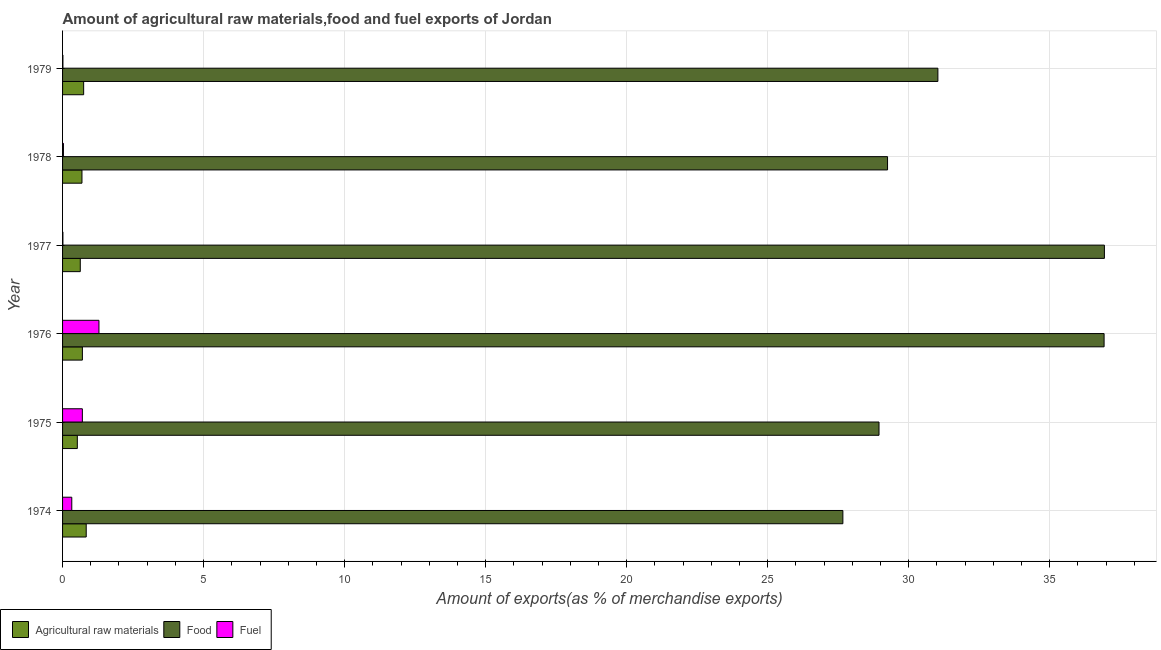How many different coloured bars are there?
Give a very brief answer. 3. Are the number of bars per tick equal to the number of legend labels?
Offer a terse response. Yes. Are the number of bars on each tick of the Y-axis equal?
Your answer should be compact. Yes. How many bars are there on the 6th tick from the top?
Ensure brevity in your answer.  3. What is the label of the 4th group of bars from the top?
Offer a very short reply. 1976. What is the percentage of fuel exports in 1975?
Provide a succinct answer. 0.7. Across all years, what is the maximum percentage of raw materials exports?
Your response must be concise. 0.84. Across all years, what is the minimum percentage of fuel exports?
Keep it short and to the point. 0.01. In which year was the percentage of food exports maximum?
Ensure brevity in your answer.  1977. In which year was the percentage of raw materials exports minimum?
Provide a succinct answer. 1975. What is the total percentage of fuel exports in the graph?
Your answer should be very brief. 2.37. What is the difference between the percentage of fuel exports in 1976 and that in 1978?
Offer a terse response. 1.26. What is the difference between the percentage of fuel exports in 1978 and the percentage of food exports in 1974?
Provide a short and direct response. -27.64. What is the average percentage of raw materials exports per year?
Offer a terse response. 0.69. In the year 1975, what is the difference between the percentage of fuel exports and percentage of raw materials exports?
Make the answer very short. 0.18. What is the ratio of the percentage of fuel exports in 1976 to that in 1977?
Your response must be concise. 107.68. What is the difference between the highest and the second highest percentage of food exports?
Make the answer very short. 0.01. What is the difference between the highest and the lowest percentage of raw materials exports?
Provide a succinct answer. 0.32. What does the 3rd bar from the top in 1976 represents?
Your answer should be compact. Agricultural raw materials. What does the 2nd bar from the bottom in 1976 represents?
Keep it short and to the point. Food. How many years are there in the graph?
Provide a succinct answer. 6. Does the graph contain any zero values?
Ensure brevity in your answer.  No. How are the legend labels stacked?
Keep it short and to the point. Horizontal. What is the title of the graph?
Give a very brief answer. Amount of agricultural raw materials,food and fuel exports of Jordan. Does "Social insurance" appear as one of the legend labels in the graph?
Your response must be concise. No. What is the label or title of the X-axis?
Keep it short and to the point. Amount of exports(as % of merchandise exports). What is the label or title of the Y-axis?
Your response must be concise. Year. What is the Amount of exports(as % of merchandise exports) in Agricultural raw materials in 1974?
Provide a succinct answer. 0.84. What is the Amount of exports(as % of merchandise exports) in Food in 1974?
Ensure brevity in your answer.  27.67. What is the Amount of exports(as % of merchandise exports) in Fuel in 1974?
Make the answer very short. 0.33. What is the Amount of exports(as % of merchandise exports) of Agricultural raw materials in 1975?
Keep it short and to the point. 0.52. What is the Amount of exports(as % of merchandise exports) of Food in 1975?
Your response must be concise. 28.95. What is the Amount of exports(as % of merchandise exports) of Fuel in 1975?
Make the answer very short. 0.7. What is the Amount of exports(as % of merchandise exports) in Agricultural raw materials in 1976?
Your answer should be compact. 0.7. What is the Amount of exports(as % of merchandise exports) in Food in 1976?
Your answer should be very brief. 36.93. What is the Amount of exports(as % of merchandise exports) of Fuel in 1976?
Offer a terse response. 1.29. What is the Amount of exports(as % of merchandise exports) in Agricultural raw materials in 1977?
Provide a short and direct response. 0.63. What is the Amount of exports(as % of merchandise exports) in Food in 1977?
Offer a very short reply. 36.94. What is the Amount of exports(as % of merchandise exports) of Fuel in 1977?
Your response must be concise. 0.01. What is the Amount of exports(as % of merchandise exports) in Agricultural raw materials in 1978?
Provide a short and direct response. 0.69. What is the Amount of exports(as % of merchandise exports) of Food in 1978?
Offer a very short reply. 29.25. What is the Amount of exports(as % of merchandise exports) in Fuel in 1978?
Provide a short and direct response. 0.03. What is the Amount of exports(as % of merchandise exports) in Agricultural raw materials in 1979?
Provide a short and direct response. 0.75. What is the Amount of exports(as % of merchandise exports) in Food in 1979?
Provide a short and direct response. 31.03. What is the Amount of exports(as % of merchandise exports) in Fuel in 1979?
Keep it short and to the point. 0.01. Across all years, what is the maximum Amount of exports(as % of merchandise exports) in Agricultural raw materials?
Offer a terse response. 0.84. Across all years, what is the maximum Amount of exports(as % of merchandise exports) of Food?
Ensure brevity in your answer.  36.94. Across all years, what is the maximum Amount of exports(as % of merchandise exports) of Fuel?
Ensure brevity in your answer.  1.29. Across all years, what is the minimum Amount of exports(as % of merchandise exports) of Agricultural raw materials?
Keep it short and to the point. 0.52. Across all years, what is the minimum Amount of exports(as % of merchandise exports) of Food?
Offer a very short reply. 27.67. Across all years, what is the minimum Amount of exports(as % of merchandise exports) in Fuel?
Keep it short and to the point. 0.01. What is the total Amount of exports(as % of merchandise exports) in Agricultural raw materials in the graph?
Give a very brief answer. 4.13. What is the total Amount of exports(as % of merchandise exports) in Food in the graph?
Your answer should be very brief. 190.77. What is the total Amount of exports(as % of merchandise exports) in Fuel in the graph?
Offer a very short reply. 2.37. What is the difference between the Amount of exports(as % of merchandise exports) in Agricultural raw materials in 1974 and that in 1975?
Provide a short and direct response. 0.32. What is the difference between the Amount of exports(as % of merchandise exports) in Food in 1974 and that in 1975?
Offer a very short reply. -1.28. What is the difference between the Amount of exports(as % of merchandise exports) in Fuel in 1974 and that in 1975?
Offer a terse response. -0.38. What is the difference between the Amount of exports(as % of merchandise exports) of Agricultural raw materials in 1974 and that in 1976?
Provide a succinct answer. 0.14. What is the difference between the Amount of exports(as % of merchandise exports) of Food in 1974 and that in 1976?
Provide a short and direct response. -9.26. What is the difference between the Amount of exports(as % of merchandise exports) of Fuel in 1974 and that in 1976?
Your answer should be very brief. -0.96. What is the difference between the Amount of exports(as % of merchandise exports) of Agricultural raw materials in 1974 and that in 1977?
Your answer should be very brief. 0.21. What is the difference between the Amount of exports(as % of merchandise exports) in Food in 1974 and that in 1977?
Keep it short and to the point. -9.27. What is the difference between the Amount of exports(as % of merchandise exports) of Fuel in 1974 and that in 1977?
Offer a terse response. 0.31. What is the difference between the Amount of exports(as % of merchandise exports) of Agricultural raw materials in 1974 and that in 1978?
Provide a short and direct response. 0.15. What is the difference between the Amount of exports(as % of merchandise exports) in Food in 1974 and that in 1978?
Offer a very short reply. -1.58. What is the difference between the Amount of exports(as % of merchandise exports) of Fuel in 1974 and that in 1978?
Offer a very short reply. 0.3. What is the difference between the Amount of exports(as % of merchandise exports) in Agricultural raw materials in 1974 and that in 1979?
Keep it short and to the point. 0.09. What is the difference between the Amount of exports(as % of merchandise exports) of Food in 1974 and that in 1979?
Your answer should be very brief. -3.37. What is the difference between the Amount of exports(as % of merchandise exports) in Fuel in 1974 and that in 1979?
Offer a very short reply. 0.31. What is the difference between the Amount of exports(as % of merchandise exports) in Agricultural raw materials in 1975 and that in 1976?
Ensure brevity in your answer.  -0.18. What is the difference between the Amount of exports(as % of merchandise exports) in Food in 1975 and that in 1976?
Your response must be concise. -7.98. What is the difference between the Amount of exports(as % of merchandise exports) in Fuel in 1975 and that in 1976?
Your answer should be very brief. -0.59. What is the difference between the Amount of exports(as % of merchandise exports) of Agricultural raw materials in 1975 and that in 1977?
Your answer should be very brief. -0.1. What is the difference between the Amount of exports(as % of merchandise exports) in Food in 1975 and that in 1977?
Ensure brevity in your answer.  -7.99. What is the difference between the Amount of exports(as % of merchandise exports) of Fuel in 1975 and that in 1977?
Offer a terse response. 0.69. What is the difference between the Amount of exports(as % of merchandise exports) of Agricultural raw materials in 1975 and that in 1978?
Your answer should be very brief. -0.16. What is the difference between the Amount of exports(as % of merchandise exports) in Food in 1975 and that in 1978?
Keep it short and to the point. -0.3. What is the difference between the Amount of exports(as % of merchandise exports) of Fuel in 1975 and that in 1978?
Your answer should be very brief. 0.67. What is the difference between the Amount of exports(as % of merchandise exports) in Agricultural raw materials in 1975 and that in 1979?
Keep it short and to the point. -0.22. What is the difference between the Amount of exports(as % of merchandise exports) of Food in 1975 and that in 1979?
Keep it short and to the point. -2.09. What is the difference between the Amount of exports(as % of merchandise exports) in Fuel in 1975 and that in 1979?
Your answer should be very brief. 0.69. What is the difference between the Amount of exports(as % of merchandise exports) in Agricultural raw materials in 1976 and that in 1977?
Offer a very short reply. 0.07. What is the difference between the Amount of exports(as % of merchandise exports) of Food in 1976 and that in 1977?
Ensure brevity in your answer.  -0.01. What is the difference between the Amount of exports(as % of merchandise exports) in Fuel in 1976 and that in 1977?
Your answer should be very brief. 1.28. What is the difference between the Amount of exports(as % of merchandise exports) in Agricultural raw materials in 1976 and that in 1978?
Offer a terse response. 0.01. What is the difference between the Amount of exports(as % of merchandise exports) in Food in 1976 and that in 1978?
Your answer should be very brief. 7.68. What is the difference between the Amount of exports(as % of merchandise exports) in Fuel in 1976 and that in 1978?
Your answer should be very brief. 1.26. What is the difference between the Amount of exports(as % of merchandise exports) of Agricultural raw materials in 1976 and that in 1979?
Keep it short and to the point. -0.04. What is the difference between the Amount of exports(as % of merchandise exports) in Food in 1976 and that in 1979?
Offer a very short reply. 5.89. What is the difference between the Amount of exports(as % of merchandise exports) of Fuel in 1976 and that in 1979?
Keep it short and to the point. 1.28. What is the difference between the Amount of exports(as % of merchandise exports) in Agricultural raw materials in 1977 and that in 1978?
Provide a succinct answer. -0.06. What is the difference between the Amount of exports(as % of merchandise exports) in Food in 1977 and that in 1978?
Offer a terse response. 7.69. What is the difference between the Amount of exports(as % of merchandise exports) of Fuel in 1977 and that in 1978?
Provide a succinct answer. -0.02. What is the difference between the Amount of exports(as % of merchandise exports) in Agricultural raw materials in 1977 and that in 1979?
Your answer should be very brief. -0.12. What is the difference between the Amount of exports(as % of merchandise exports) of Food in 1977 and that in 1979?
Provide a short and direct response. 5.9. What is the difference between the Amount of exports(as % of merchandise exports) in Fuel in 1977 and that in 1979?
Provide a short and direct response. -0. What is the difference between the Amount of exports(as % of merchandise exports) of Agricultural raw materials in 1978 and that in 1979?
Offer a terse response. -0.06. What is the difference between the Amount of exports(as % of merchandise exports) of Food in 1978 and that in 1979?
Your answer should be very brief. -1.78. What is the difference between the Amount of exports(as % of merchandise exports) of Fuel in 1978 and that in 1979?
Provide a short and direct response. 0.02. What is the difference between the Amount of exports(as % of merchandise exports) in Agricultural raw materials in 1974 and the Amount of exports(as % of merchandise exports) in Food in 1975?
Offer a terse response. -28.11. What is the difference between the Amount of exports(as % of merchandise exports) of Agricultural raw materials in 1974 and the Amount of exports(as % of merchandise exports) of Fuel in 1975?
Make the answer very short. 0.14. What is the difference between the Amount of exports(as % of merchandise exports) in Food in 1974 and the Amount of exports(as % of merchandise exports) in Fuel in 1975?
Provide a succinct answer. 26.96. What is the difference between the Amount of exports(as % of merchandise exports) in Agricultural raw materials in 1974 and the Amount of exports(as % of merchandise exports) in Food in 1976?
Make the answer very short. -36.09. What is the difference between the Amount of exports(as % of merchandise exports) in Agricultural raw materials in 1974 and the Amount of exports(as % of merchandise exports) in Fuel in 1976?
Keep it short and to the point. -0.45. What is the difference between the Amount of exports(as % of merchandise exports) in Food in 1974 and the Amount of exports(as % of merchandise exports) in Fuel in 1976?
Offer a very short reply. 26.38. What is the difference between the Amount of exports(as % of merchandise exports) of Agricultural raw materials in 1974 and the Amount of exports(as % of merchandise exports) of Food in 1977?
Offer a very short reply. -36.1. What is the difference between the Amount of exports(as % of merchandise exports) in Agricultural raw materials in 1974 and the Amount of exports(as % of merchandise exports) in Fuel in 1977?
Provide a short and direct response. 0.83. What is the difference between the Amount of exports(as % of merchandise exports) of Food in 1974 and the Amount of exports(as % of merchandise exports) of Fuel in 1977?
Your answer should be very brief. 27.65. What is the difference between the Amount of exports(as % of merchandise exports) in Agricultural raw materials in 1974 and the Amount of exports(as % of merchandise exports) in Food in 1978?
Your answer should be compact. -28.41. What is the difference between the Amount of exports(as % of merchandise exports) of Agricultural raw materials in 1974 and the Amount of exports(as % of merchandise exports) of Fuel in 1978?
Provide a succinct answer. 0.81. What is the difference between the Amount of exports(as % of merchandise exports) in Food in 1974 and the Amount of exports(as % of merchandise exports) in Fuel in 1978?
Keep it short and to the point. 27.64. What is the difference between the Amount of exports(as % of merchandise exports) of Agricultural raw materials in 1974 and the Amount of exports(as % of merchandise exports) of Food in 1979?
Provide a succinct answer. -30.2. What is the difference between the Amount of exports(as % of merchandise exports) of Agricultural raw materials in 1974 and the Amount of exports(as % of merchandise exports) of Fuel in 1979?
Provide a succinct answer. 0.83. What is the difference between the Amount of exports(as % of merchandise exports) of Food in 1974 and the Amount of exports(as % of merchandise exports) of Fuel in 1979?
Ensure brevity in your answer.  27.65. What is the difference between the Amount of exports(as % of merchandise exports) in Agricultural raw materials in 1975 and the Amount of exports(as % of merchandise exports) in Food in 1976?
Your answer should be very brief. -36.4. What is the difference between the Amount of exports(as % of merchandise exports) in Agricultural raw materials in 1975 and the Amount of exports(as % of merchandise exports) in Fuel in 1976?
Your answer should be compact. -0.77. What is the difference between the Amount of exports(as % of merchandise exports) of Food in 1975 and the Amount of exports(as % of merchandise exports) of Fuel in 1976?
Provide a short and direct response. 27.66. What is the difference between the Amount of exports(as % of merchandise exports) of Agricultural raw materials in 1975 and the Amount of exports(as % of merchandise exports) of Food in 1977?
Make the answer very short. -36.42. What is the difference between the Amount of exports(as % of merchandise exports) of Agricultural raw materials in 1975 and the Amount of exports(as % of merchandise exports) of Fuel in 1977?
Your answer should be compact. 0.51. What is the difference between the Amount of exports(as % of merchandise exports) in Food in 1975 and the Amount of exports(as % of merchandise exports) in Fuel in 1977?
Keep it short and to the point. 28.94. What is the difference between the Amount of exports(as % of merchandise exports) in Agricultural raw materials in 1975 and the Amount of exports(as % of merchandise exports) in Food in 1978?
Provide a succinct answer. -28.73. What is the difference between the Amount of exports(as % of merchandise exports) of Agricultural raw materials in 1975 and the Amount of exports(as % of merchandise exports) of Fuel in 1978?
Offer a very short reply. 0.49. What is the difference between the Amount of exports(as % of merchandise exports) in Food in 1975 and the Amount of exports(as % of merchandise exports) in Fuel in 1978?
Give a very brief answer. 28.92. What is the difference between the Amount of exports(as % of merchandise exports) in Agricultural raw materials in 1975 and the Amount of exports(as % of merchandise exports) in Food in 1979?
Give a very brief answer. -30.51. What is the difference between the Amount of exports(as % of merchandise exports) in Agricultural raw materials in 1975 and the Amount of exports(as % of merchandise exports) in Fuel in 1979?
Provide a succinct answer. 0.51. What is the difference between the Amount of exports(as % of merchandise exports) of Food in 1975 and the Amount of exports(as % of merchandise exports) of Fuel in 1979?
Your answer should be very brief. 28.93. What is the difference between the Amount of exports(as % of merchandise exports) of Agricultural raw materials in 1976 and the Amount of exports(as % of merchandise exports) of Food in 1977?
Offer a very short reply. -36.24. What is the difference between the Amount of exports(as % of merchandise exports) in Agricultural raw materials in 1976 and the Amount of exports(as % of merchandise exports) in Fuel in 1977?
Give a very brief answer. 0.69. What is the difference between the Amount of exports(as % of merchandise exports) in Food in 1976 and the Amount of exports(as % of merchandise exports) in Fuel in 1977?
Offer a terse response. 36.92. What is the difference between the Amount of exports(as % of merchandise exports) in Agricultural raw materials in 1976 and the Amount of exports(as % of merchandise exports) in Food in 1978?
Ensure brevity in your answer.  -28.55. What is the difference between the Amount of exports(as % of merchandise exports) in Agricultural raw materials in 1976 and the Amount of exports(as % of merchandise exports) in Fuel in 1978?
Ensure brevity in your answer.  0.67. What is the difference between the Amount of exports(as % of merchandise exports) of Food in 1976 and the Amount of exports(as % of merchandise exports) of Fuel in 1978?
Your response must be concise. 36.9. What is the difference between the Amount of exports(as % of merchandise exports) in Agricultural raw materials in 1976 and the Amount of exports(as % of merchandise exports) in Food in 1979?
Offer a terse response. -30.33. What is the difference between the Amount of exports(as % of merchandise exports) of Agricultural raw materials in 1976 and the Amount of exports(as % of merchandise exports) of Fuel in 1979?
Provide a succinct answer. 0.69. What is the difference between the Amount of exports(as % of merchandise exports) of Food in 1976 and the Amount of exports(as % of merchandise exports) of Fuel in 1979?
Offer a terse response. 36.91. What is the difference between the Amount of exports(as % of merchandise exports) in Agricultural raw materials in 1977 and the Amount of exports(as % of merchandise exports) in Food in 1978?
Offer a terse response. -28.62. What is the difference between the Amount of exports(as % of merchandise exports) in Agricultural raw materials in 1977 and the Amount of exports(as % of merchandise exports) in Fuel in 1978?
Provide a short and direct response. 0.6. What is the difference between the Amount of exports(as % of merchandise exports) of Food in 1977 and the Amount of exports(as % of merchandise exports) of Fuel in 1978?
Offer a terse response. 36.91. What is the difference between the Amount of exports(as % of merchandise exports) of Agricultural raw materials in 1977 and the Amount of exports(as % of merchandise exports) of Food in 1979?
Your response must be concise. -30.41. What is the difference between the Amount of exports(as % of merchandise exports) of Agricultural raw materials in 1977 and the Amount of exports(as % of merchandise exports) of Fuel in 1979?
Ensure brevity in your answer.  0.62. What is the difference between the Amount of exports(as % of merchandise exports) of Food in 1977 and the Amount of exports(as % of merchandise exports) of Fuel in 1979?
Your answer should be compact. 36.93. What is the difference between the Amount of exports(as % of merchandise exports) in Agricultural raw materials in 1978 and the Amount of exports(as % of merchandise exports) in Food in 1979?
Offer a very short reply. -30.35. What is the difference between the Amount of exports(as % of merchandise exports) in Agricultural raw materials in 1978 and the Amount of exports(as % of merchandise exports) in Fuel in 1979?
Your answer should be very brief. 0.68. What is the difference between the Amount of exports(as % of merchandise exports) in Food in 1978 and the Amount of exports(as % of merchandise exports) in Fuel in 1979?
Give a very brief answer. 29.24. What is the average Amount of exports(as % of merchandise exports) in Agricultural raw materials per year?
Provide a short and direct response. 0.69. What is the average Amount of exports(as % of merchandise exports) in Food per year?
Provide a short and direct response. 31.79. What is the average Amount of exports(as % of merchandise exports) in Fuel per year?
Give a very brief answer. 0.4. In the year 1974, what is the difference between the Amount of exports(as % of merchandise exports) in Agricultural raw materials and Amount of exports(as % of merchandise exports) in Food?
Make the answer very short. -26.83. In the year 1974, what is the difference between the Amount of exports(as % of merchandise exports) in Agricultural raw materials and Amount of exports(as % of merchandise exports) in Fuel?
Ensure brevity in your answer.  0.51. In the year 1974, what is the difference between the Amount of exports(as % of merchandise exports) in Food and Amount of exports(as % of merchandise exports) in Fuel?
Your answer should be compact. 27.34. In the year 1975, what is the difference between the Amount of exports(as % of merchandise exports) of Agricultural raw materials and Amount of exports(as % of merchandise exports) of Food?
Your response must be concise. -28.42. In the year 1975, what is the difference between the Amount of exports(as % of merchandise exports) in Agricultural raw materials and Amount of exports(as % of merchandise exports) in Fuel?
Give a very brief answer. -0.18. In the year 1975, what is the difference between the Amount of exports(as % of merchandise exports) in Food and Amount of exports(as % of merchandise exports) in Fuel?
Provide a succinct answer. 28.25. In the year 1976, what is the difference between the Amount of exports(as % of merchandise exports) in Agricultural raw materials and Amount of exports(as % of merchandise exports) in Food?
Provide a short and direct response. -36.22. In the year 1976, what is the difference between the Amount of exports(as % of merchandise exports) in Agricultural raw materials and Amount of exports(as % of merchandise exports) in Fuel?
Ensure brevity in your answer.  -0.59. In the year 1976, what is the difference between the Amount of exports(as % of merchandise exports) in Food and Amount of exports(as % of merchandise exports) in Fuel?
Offer a terse response. 35.64. In the year 1977, what is the difference between the Amount of exports(as % of merchandise exports) in Agricultural raw materials and Amount of exports(as % of merchandise exports) in Food?
Your answer should be compact. -36.31. In the year 1977, what is the difference between the Amount of exports(as % of merchandise exports) in Agricultural raw materials and Amount of exports(as % of merchandise exports) in Fuel?
Your response must be concise. 0.62. In the year 1977, what is the difference between the Amount of exports(as % of merchandise exports) in Food and Amount of exports(as % of merchandise exports) in Fuel?
Ensure brevity in your answer.  36.93. In the year 1978, what is the difference between the Amount of exports(as % of merchandise exports) of Agricultural raw materials and Amount of exports(as % of merchandise exports) of Food?
Your answer should be compact. -28.56. In the year 1978, what is the difference between the Amount of exports(as % of merchandise exports) in Agricultural raw materials and Amount of exports(as % of merchandise exports) in Fuel?
Keep it short and to the point. 0.66. In the year 1978, what is the difference between the Amount of exports(as % of merchandise exports) of Food and Amount of exports(as % of merchandise exports) of Fuel?
Provide a short and direct response. 29.22. In the year 1979, what is the difference between the Amount of exports(as % of merchandise exports) of Agricultural raw materials and Amount of exports(as % of merchandise exports) of Food?
Provide a short and direct response. -30.29. In the year 1979, what is the difference between the Amount of exports(as % of merchandise exports) in Agricultural raw materials and Amount of exports(as % of merchandise exports) in Fuel?
Offer a very short reply. 0.74. In the year 1979, what is the difference between the Amount of exports(as % of merchandise exports) of Food and Amount of exports(as % of merchandise exports) of Fuel?
Keep it short and to the point. 31.02. What is the ratio of the Amount of exports(as % of merchandise exports) of Agricultural raw materials in 1974 to that in 1975?
Make the answer very short. 1.6. What is the ratio of the Amount of exports(as % of merchandise exports) of Food in 1974 to that in 1975?
Your answer should be compact. 0.96. What is the ratio of the Amount of exports(as % of merchandise exports) of Fuel in 1974 to that in 1975?
Your answer should be very brief. 0.47. What is the ratio of the Amount of exports(as % of merchandise exports) in Agricultural raw materials in 1974 to that in 1976?
Offer a terse response. 1.19. What is the ratio of the Amount of exports(as % of merchandise exports) in Food in 1974 to that in 1976?
Ensure brevity in your answer.  0.75. What is the ratio of the Amount of exports(as % of merchandise exports) of Fuel in 1974 to that in 1976?
Your answer should be very brief. 0.25. What is the ratio of the Amount of exports(as % of merchandise exports) of Agricultural raw materials in 1974 to that in 1977?
Provide a succinct answer. 1.34. What is the ratio of the Amount of exports(as % of merchandise exports) in Food in 1974 to that in 1977?
Your answer should be compact. 0.75. What is the ratio of the Amount of exports(as % of merchandise exports) of Fuel in 1974 to that in 1977?
Give a very brief answer. 27.28. What is the ratio of the Amount of exports(as % of merchandise exports) in Agricultural raw materials in 1974 to that in 1978?
Offer a very short reply. 1.22. What is the ratio of the Amount of exports(as % of merchandise exports) in Food in 1974 to that in 1978?
Give a very brief answer. 0.95. What is the ratio of the Amount of exports(as % of merchandise exports) in Fuel in 1974 to that in 1978?
Your response must be concise. 10.64. What is the ratio of the Amount of exports(as % of merchandise exports) of Agricultural raw materials in 1974 to that in 1979?
Your answer should be very brief. 1.12. What is the ratio of the Amount of exports(as % of merchandise exports) in Food in 1974 to that in 1979?
Keep it short and to the point. 0.89. What is the ratio of the Amount of exports(as % of merchandise exports) in Fuel in 1974 to that in 1979?
Provide a succinct answer. 25.56. What is the ratio of the Amount of exports(as % of merchandise exports) of Agricultural raw materials in 1975 to that in 1976?
Your answer should be compact. 0.74. What is the ratio of the Amount of exports(as % of merchandise exports) in Food in 1975 to that in 1976?
Offer a very short reply. 0.78. What is the ratio of the Amount of exports(as % of merchandise exports) of Fuel in 1975 to that in 1976?
Your answer should be very brief. 0.54. What is the ratio of the Amount of exports(as % of merchandise exports) in Agricultural raw materials in 1975 to that in 1977?
Your answer should be compact. 0.83. What is the ratio of the Amount of exports(as % of merchandise exports) in Food in 1975 to that in 1977?
Your answer should be compact. 0.78. What is the ratio of the Amount of exports(as % of merchandise exports) of Fuel in 1975 to that in 1977?
Ensure brevity in your answer.  58.57. What is the ratio of the Amount of exports(as % of merchandise exports) in Agricultural raw materials in 1975 to that in 1978?
Offer a terse response. 0.76. What is the ratio of the Amount of exports(as % of merchandise exports) of Fuel in 1975 to that in 1978?
Your response must be concise. 22.85. What is the ratio of the Amount of exports(as % of merchandise exports) of Agricultural raw materials in 1975 to that in 1979?
Make the answer very short. 0.7. What is the ratio of the Amount of exports(as % of merchandise exports) of Food in 1975 to that in 1979?
Ensure brevity in your answer.  0.93. What is the ratio of the Amount of exports(as % of merchandise exports) of Fuel in 1975 to that in 1979?
Offer a very short reply. 54.88. What is the ratio of the Amount of exports(as % of merchandise exports) of Agricultural raw materials in 1976 to that in 1977?
Keep it short and to the point. 1.12. What is the ratio of the Amount of exports(as % of merchandise exports) in Fuel in 1976 to that in 1977?
Ensure brevity in your answer.  107.68. What is the ratio of the Amount of exports(as % of merchandise exports) of Agricultural raw materials in 1976 to that in 1978?
Give a very brief answer. 1.02. What is the ratio of the Amount of exports(as % of merchandise exports) of Food in 1976 to that in 1978?
Give a very brief answer. 1.26. What is the ratio of the Amount of exports(as % of merchandise exports) in Fuel in 1976 to that in 1978?
Your answer should be compact. 42.01. What is the ratio of the Amount of exports(as % of merchandise exports) in Food in 1976 to that in 1979?
Your response must be concise. 1.19. What is the ratio of the Amount of exports(as % of merchandise exports) in Fuel in 1976 to that in 1979?
Provide a succinct answer. 100.88. What is the ratio of the Amount of exports(as % of merchandise exports) in Agricultural raw materials in 1977 to that in 1978?
Offer a terse response. 0.91. What is the ratio of the Amount of exports(as % of merchandise exports) in Food in 1977 to that in 1978?
Your answer should be very brief. 1.26. What is the ratio of the Amount of exports(as % of merchandise exports) in Fuel in 1977 to that in 1978?
Provide a succinct answer. 0.39. What is the ratio of the Amount of exports(as % of merchandise exports) in Agricultural raw materials in 1977 to that in 1979?
Keep it short and to the point. 0.84. What is the ratio of the Amount of exports(as % of merchandise exports) of Food in 1977 to that in 1979?
Ensure brevity in your answer.  1.19. What is the ratio of the Amount of exports(as % of merchandise exports) of Fuel in 1977 to that in 1979?
Ensure brevity in your answer.  0.94. What is the ratio of the Amount of exports(as % of merchandise exports) in Agricultural raw materials in 1978 to that in 1979?
Your answer should be compact. 0.92. What is the ratio of the Amount of exports(as % of merchandise exports) in Food in 1978 to that in 1979?
Offer a very short reply. 0.94. What is the ratio of the Amount of exports(as % of merchandise exports) in Fuel in 1978 to that in 1979?
Provide a succinct answer. 2.4. What is the difference between the highest and the second highest Amount of exports(as % of merchandise exports) of Agricultural raw materials?
Make the answer very short. 0.09. What is the difference between the highest and the second highest Amount of exports(as % of merchandise exports) in Food?
Your response must be concise. 0.01. What is the difference between the highest and the second highest Amount of exports(as % of merchandise exports) in Fuel?
Keep it short and to the point. 0.59. What is the difference between the highest and the lowest Amount of exports(as % of merchandise exports) in Agricultural raw materials?
Make the answer very short. 0.32. What is the difference between the highest and the lowest Amount of exports(as % of merchandise exports) in Food?
Provide a short and direct response. 9.27. What is the difference between the highest and the lowest Amount of exports(as % of merchandise exports) of Fuel?
Provide a short and direct response. 1.28. 